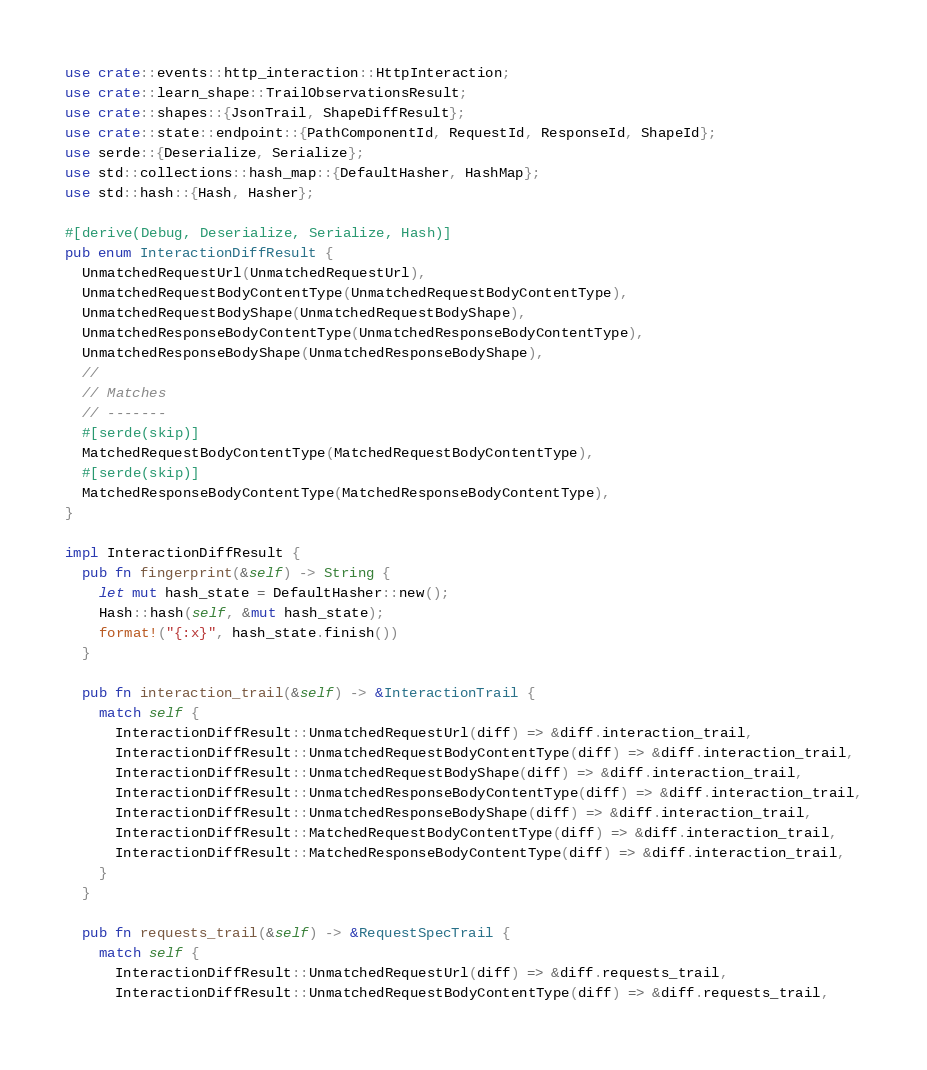Convert code to text. <code><loc_0><loc_0><loc_500><loc_500><_Rust_>use crate::events::http_interaction::HttpInteraction;
use crate::learn_shape::TrailObservationsResult;
use crate::shapes::{JsonTrail, ShapeDiffResult};
use crate::state::endpoint::{PathComponentId, RequestId, ResponseId, ShapeId};
use serde::{Deserialize, Serialize};
use std::collections::hash_map::{DefaultHasher, HashMap};
use std::hash::{Hash, Hasher};

#[derive(Debug, Deserialize, Serialize, Hash)]
pub enum InteractionDiffResult {
  UnmatchedRequestUrl(UnmatchedRequestUrl),
  UnmatchedRequestBodyContentType(UnmatchedRequestBodyContentType),
  UnmatchedRequestBodyShape(UnmatchedRequestBodyShape),
  UnmatchedResponseBodyContentType(UnmatchedResponseBodyContentType),
  UnmatchedResponseBodyShape(UnmatchedResponseBodyShape),
  //
  // Matches
  // -------
  #[serde(skip)]
  MatchedRequestBodyContentType(MatchedRequestBodyContentType),
  #[serde(skip)]
  MatchedResponseBodyContentType(MatchedResponseBodyContentType),
}

impl InteractionDiffResult {
  pub fn fingerprint(&self) -> String {
    let mut hash_state = DefaultHasher::new();
    Hash::hash(self, &mut hash_state);
    format!("{:x}", hash_state.finish())
  }

  pub fn interaction_trail(&self) -> &InteractionTrail {
    match self {
      InteractionDiffResult::UnmatchedRequestUrl(diff) => &diff.interaction_trail,
      InteractionDiffResult::UnmatchedRequestBodyContentType(diff) => &diff.interaction_trail,
      InteractionDiffResult::UnmatchedRequestBodyShape(diff) => &diff.interaction_trail,
      InteractionDiffResult::UnmatchedResponseBodyContentType(diff) => &diff.interaction_trail,
      InteractionDiffResult::UnmatchedResponseBodyShape(diff) => &diff.interaction_trail,
      InteractionDiffResult::MatchedRequestBodyContentType(diff) => &diff.interaction_trail,
      InteractionDiffResult::MatchedResponseBodyContentType(diff) => &diff.interaction_trail,
    }
  }

  pub fn requests_trail(&self) -> &RequestSpecTrail {
    match self {
      InteractionDiffResult::UnmatchedRequestUrl(diff) => &diff.requests_trail,
      InteractionDiffResult::UnmatchedRequestBodyContentType(diff) => &diff.requests_trail,</code> 